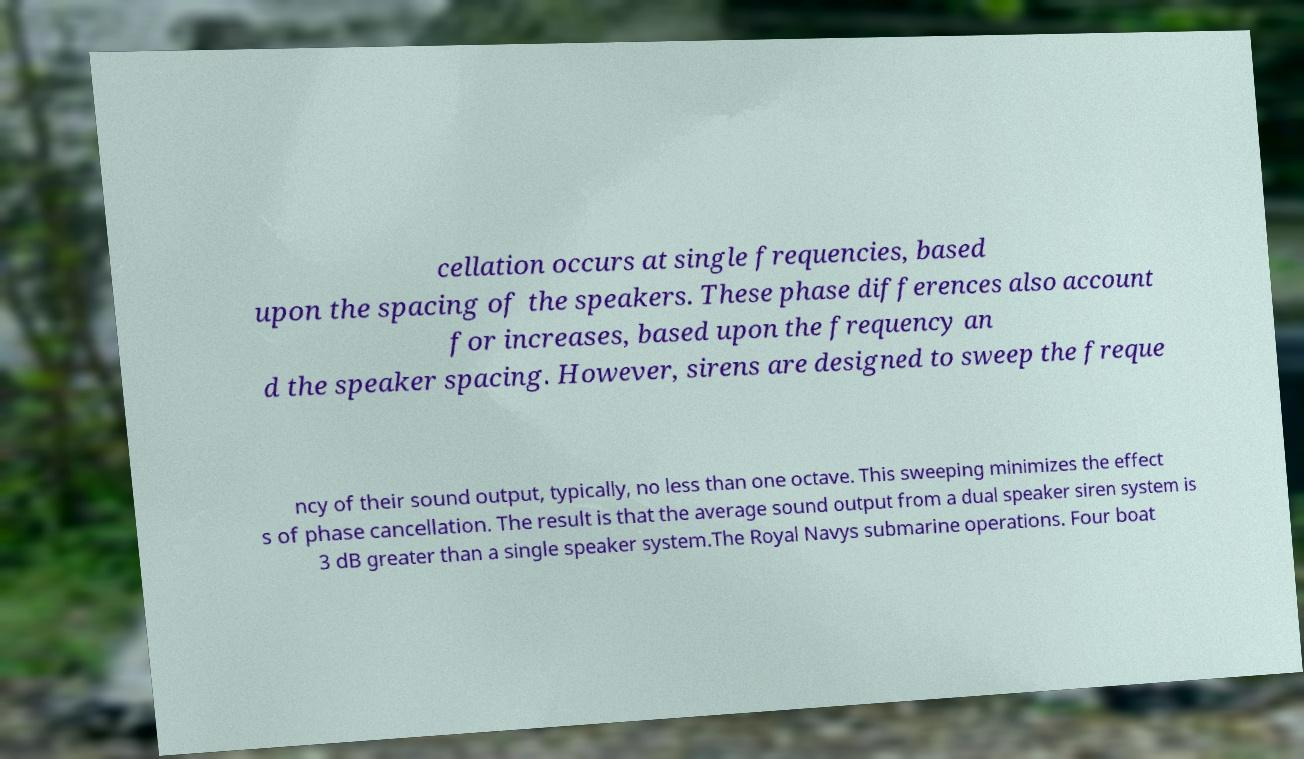For documentation purposes, I need the text within this image transcribed. Could you provide that? cellation occurs at single frequencies, based upon the spacing of the speakers. These phase differences also account for increases, based upon the frequency an d the speaker spacing. However, sirens are designed to sweep the freque ncy of their sound output, typically, no less than one octave. This sweeping minimizes the effect s of phase cancellation. The result is that the average sound output from a dual speaker siren system is 3 dB greater than a single speaker system.The Royal Navys submarine operations. Four boat 